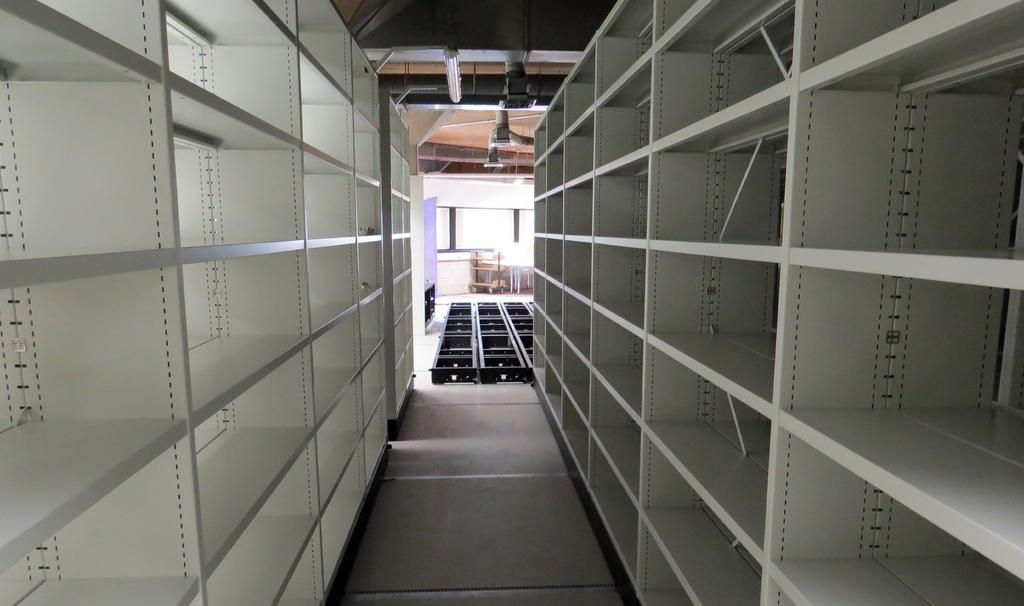What type of structure can be seen in the image? There are racks in the image. What is covering the top of the structure? There are roofs visible in the image. What is providing illumination in the image? There are lights in the image. What is on the ground in the image? There are objects on the floor in the image. How many berries are hanging from the racks in the image? There are no berries present in the image; the racks are not related to berries. What type of rail can be seen connecting the racks in the image? There is no rail connecting the racks in the image; the racks are not connected by a rail. 